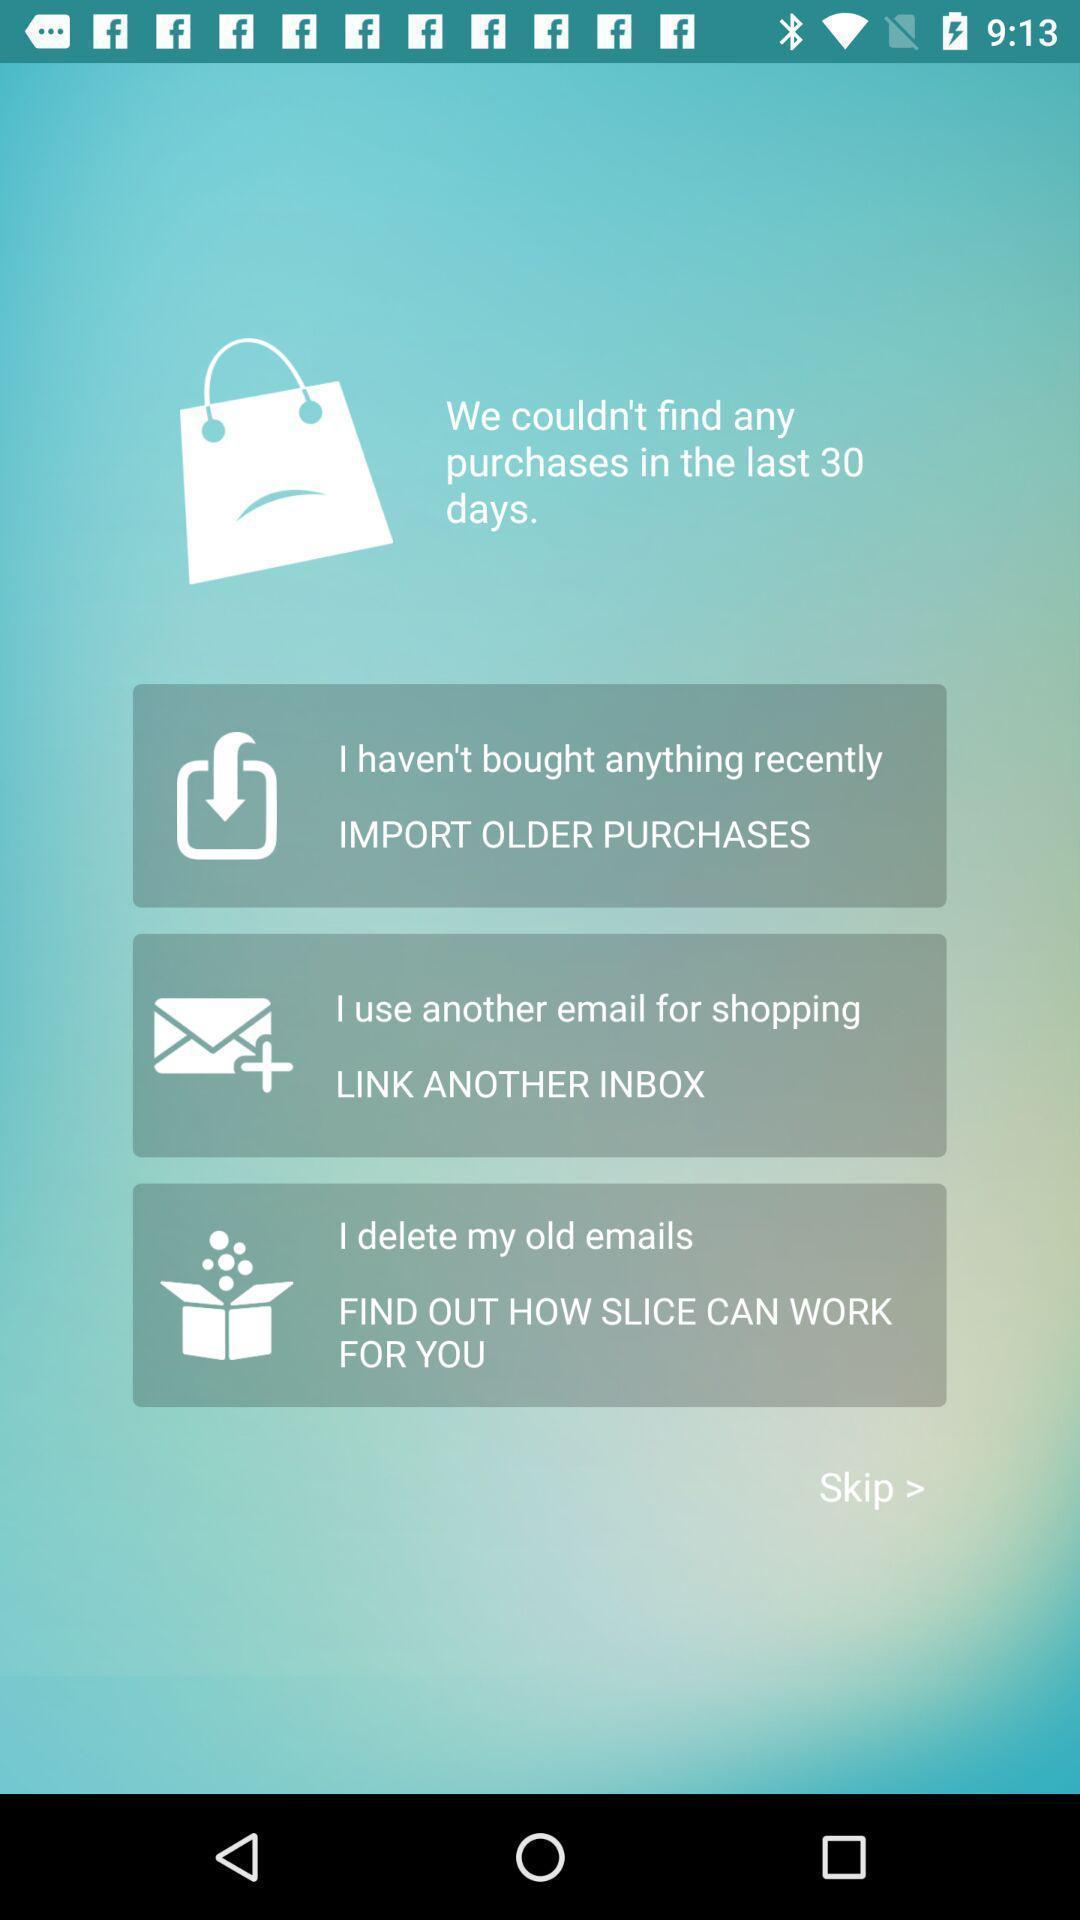Give me a summary of this screen capture. Starting page of a shopping app. 